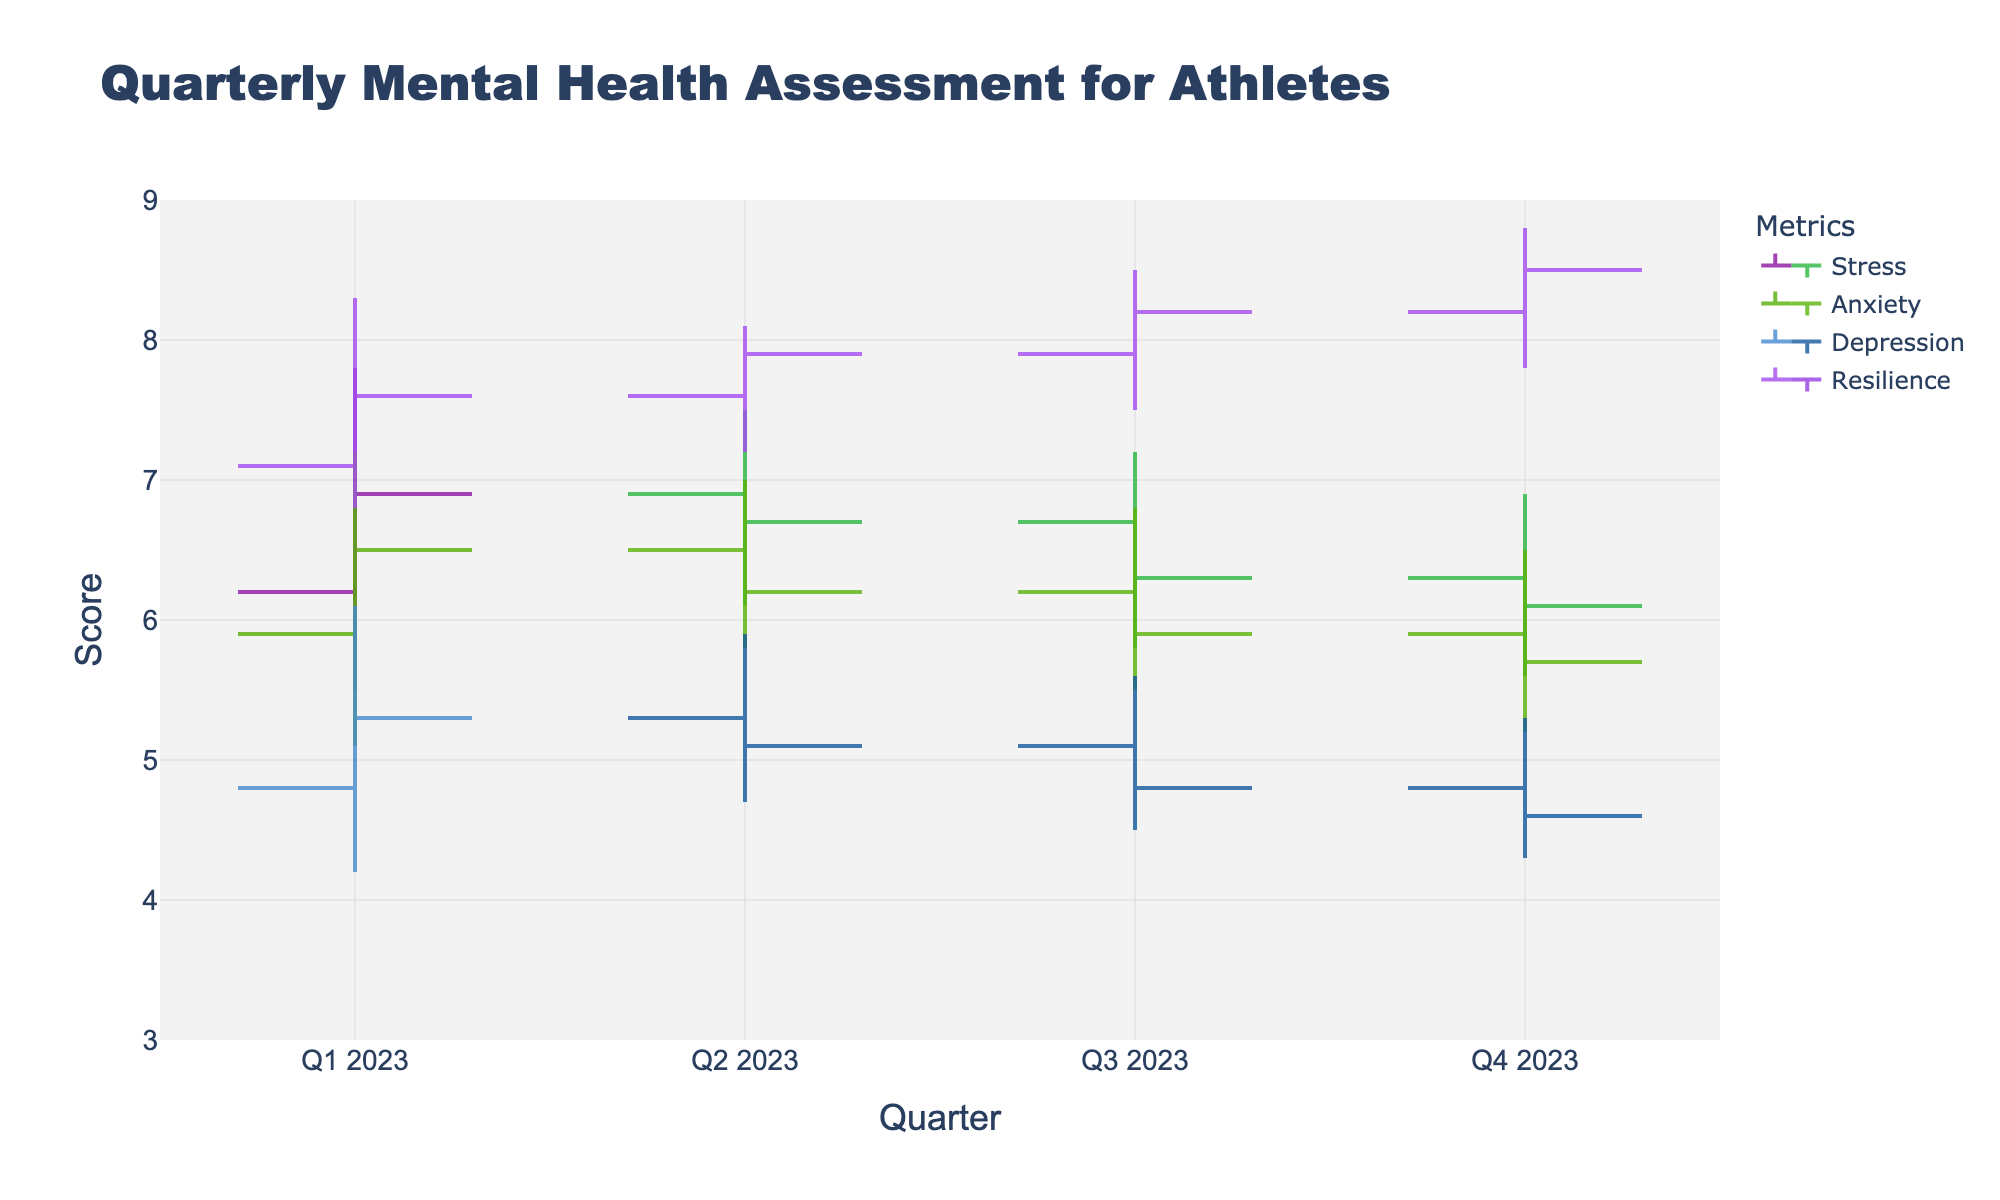what's the title of the chart? The title is located at the top of the figure and summarizes the subject of the chart. The title reads "Quarterly Mental Health Assessment for Athletes."
Answer: Quarterly Mental Health Assessment for Athletes how many quarters are displayed on the x-axis? The x-axis represents time periods divided into quarters for the year 2023. By looking at the values on the x-axis, we can see Q1 2023, Q2 2023, Q3 2023, and Q4 2023.
Answer: 4 which metric has the highest 'High' value in Q4 2023? To determine which metric, look at the 'High' values in Q4 2023 for Stress, Anxiety, Depression, and Resilience. Resilience has the highest 'High' value of 8.8.
Answer: Resilience what is the difference between Stress 'Open' and Resilience 'Close' in Q1 2023? Look at the 'Open' value for Stress in Q1 2023, which is 6.2, and the 'Close' value for Resilience in the same period, which is 7.6. The difference is calculated as 7.6 - 6.2 = 1.4.
Answer: 1.4 which quarter shows an increasing trend for the Anxiety metric? An increasing trend happens when the 'Close' value is higher than the 'Open' value. By checking 'Close' and 'Open' values for Anxiety in each quarter, we can see that Q1 2023 (6.5 > 5.9) shows an increasing trend.
Answer: Q1 2023 how many metrics show a decreasing trend in Q4 2023? A decreasing trend is observed when the 'Close' value is less than the 'Open' value. By comparing 'Close' and 'Open' values for each metric in Q4 2023: Stress (6.1 < 6.3), Anxiety (5.7 < 5.9), Depression (4.6 < 4.8), and Resilience (8.5 > 8.2). Three metrics (Stress, Anxiety, Depression) show a decreasing trend.
Answer: 3 which quarter has the lowest 'Low' value for Stress? By analyzing the 'Low' values across all quarters for Stress: Q1 (5.5), Q2 (6.1), Q3 (5.8), Q4 (5.6), we find that Q1 2023 has the lowest 'Low' value of 5.5.
Answer: Q1 2023 what's the range difference between the 'High' and 'Low' values for Depression in Q3 2023? For Q3 2023, the 'High' value for Depression is 5.6 and the 'Low' value is 4.5. The range difference can be calculated as 5.6 - 4.5 = 1.1.
Answer: 1.1 compare the 'Close' values of Resilience and Depression in Q3 2023, which is higher? The 'Close' value for Resilience in Q3 2023 is 8.2, while for Depression, it is 4.8. Since 8.2 is greater than 4.8, Resilience has the higher 'Close' value.
Answer: Resilience 